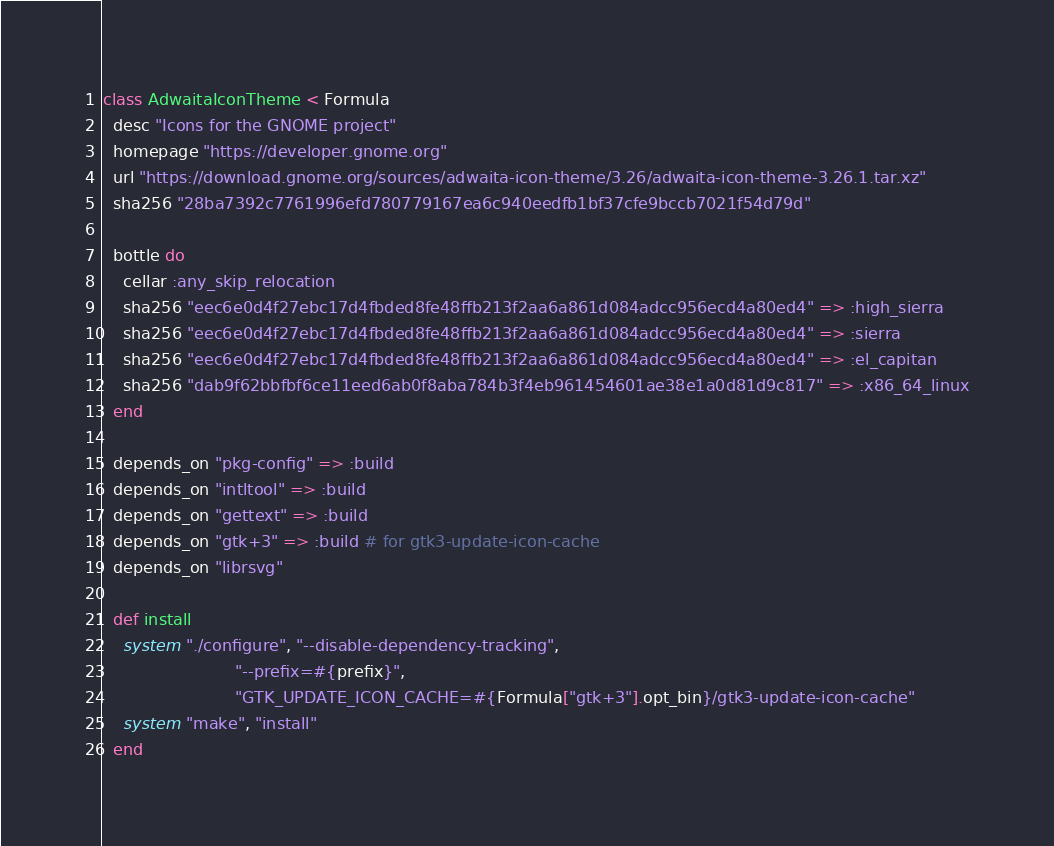Convert code to text. <code><loc_0><loc_0><loc_500><loc_500><_Ruby_>class AdwaitaIconTheme < Formula
  desc "Icons for the GNOME project"
  homepage "https://developer.gnome.org"
  url "https://download.gnome.org/sources/adwaita-icon-theme/3.26/adwaita-icon-theme-3.26.1.tar.xz"
  sha256 "28ba7392c7761996efd780779167ea6c940eedfb1bf37cfe9bccb7021f54d79d"

  bottle do
    cellar :any_skip_relocation
    sha256 "eec6e0d4f27ebc17d4fbded8fe48ffb213f2aa6a861d084adcc956ecd4a80ed4" => :high_sierra
    sha256 "eec6e0d4f27ebc17d4fbded8fe48ffb213f2aa6a861d084adcc956ecd4a80ed4" => :sierra
    sha256 "eec6e0d4f27ebc17d4fbded8fe48ffb213f2aa6a861d084adcc956ecd4a80ed4" => :el_capitan
    sha256 "dab9f62bbfbf6ce11eed6ab0f8aba784b3f4eb961454601ae38e1a0d81d9c817" => :x86_64_linux
  end

  depends_on "pkg-config" => :build
  depends_on "intltool" => :build
  depends_on "gettext" => :build
  depends_on "gtk+3" => :build # for gtk3-update-icon-cache
  depends_on "librsvg"

  def install
    system "./configure", "--disable-dependency-tracking",
                          "--prefix=#{prefix}",
                          "GTK_UPDATE_ICON_CACHE=#{Formula["gtk+3"].opt_bin}/gtk3-update-icon-cache"
    system "make", "install"
  end
</code> 